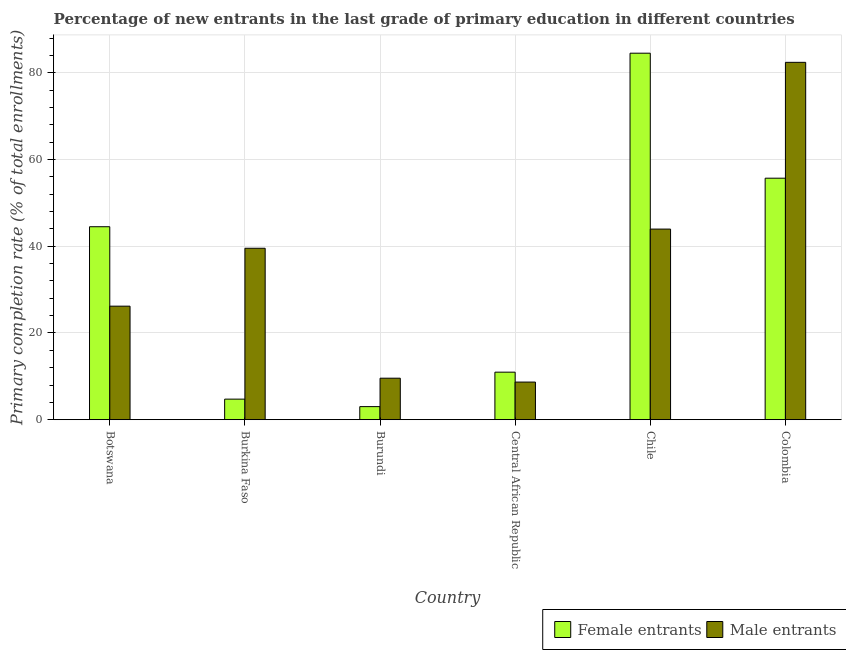Are the number of bars per tick equal to the number of legend labels?
Make the answer very short. Yes. Are the number of bars on each tick of the X-axis equal?
Your answer should be compact. Yes. What is the label of the 3rd group of bars from the left?
Offer a very short reply. Burundi. In how many cases, is the number of bars for a given country not equal to the number of legend labels?
Your response must be concise. 0. What is the primary completion rate of female entrants in Central African Republic?
Your response must be concise. 10.96. Across all countries, what is the maximum primary completion rate of male entrants?
Make the answer very short. 82.42. Across all countries, what is the minimum primary completion rate of female entrants?
Provide a succinct answer. 3.02. In which country was the primary completion rate of female entrants maximum?
Your answer should be compact. Chile. In which country was the primary completion rate of male entrants minimum?
Offer a very short reply. Central African Republic. What is the total primary completion rate of male entrants in the graph?
Give a very brief answer. 210.36. What is the difference between the primary completion rate of male entrants in Burkina Faso and that in Burundi?
Provide a short and direct response. 29.97. What is the difference between the primary completion rate of male entrants in Burkina Faso and the primary completion rate of female entrants in Burundi?
Provide a short and direct response. 36.52. What is the average primary completion rate of male entrants per country?
Your answer should be compact. 35.06. What is the difference between the primary completion rate of female entrants and primary completion rate of male entrants in Chile?
Provide a short and direct response. 40.57. What is the ratio of the primary completion rate of female entrants in Chile to that in Colombia?
Your answer should be very brief. 1.52. Is the primary completion rate of male entrants in Burkina Faso less than that in Central African Republic?
Ensure brevity in your answer.  No. Is the difference between the primary completion rate of male entrants in Botswana and Colombia greater than the difference between the primary completion rate of female entrants in Botswana and Colombia?
Provide a short and direct response. No. What is the difference between the highest and the second highest primary completion rate of male entrants?
Your answer should be compact. 38.46. What is the difference between the highest and the lowest primary completion rate of male entrants?
Offer a very short reply. 73.74. Is the sum of the primary completion rate of male entrants in Burkina Faso and Central African Republic greater than the maximum primary completion rate of female entrants across all countries?
Give a very brief answer. No. What does the 2nd bar from the left in Burundi represents?
Keep it short and to the point. Male entrants. What does the 1st bar from the right in Chile represents?
Provide a succinct answer. Male entrants. How many bars are there?
Keep it short and to the point. 12. What is the difference between two consecutive major ticks on the Y-axis?
Your answer should be very brief. 20. Does the graph contain any zero values?
Make the answer very short. No. Does the graph contain grids?
Your response must be concise. Yes. How are the legend labels stacked?
Give a very brief answer. Horizontal. What is the title of the graph?
Ensure brevity in your answer.  Percentage of new entrants in the last grade of primary education in different countries. What is the label or title of the X-axis?
Provide a succinct answer. Country. What is the label or title of the Y-axis?
Keep it short and to the point. Primary completion rate (% of total enrollments). What is the Primary completion rate (% of total enrollments) in Female entrants in Botswana?
Your answer should be very brief. 44.51. What is the Primary completion rate (% of total enrollments) in Male entrants in Botswana?
Make the answer very short. 26.19. What is the Primary completion rate (% of total enrollments) of Female entrants in Burkina Faso?
Make the answer very short. 4.74. What is the Primary completion rate (% of total enrollments) of Male entrants in Burkina Faso?
Offer a terse response. 39.54. What is the Primary completion rate (% of total enrollments) in Female entrants in Burundi?
Offer a terse response. 3.02. What is the Primary completion rate (% of total enrollments) in Male entrants in Burundi?
Provide a short and direct response. 9.57. What is the Primary completion rate (% of total enrollments) in Female entrants in Central African Republic?
Provide a succinct answer. 10.96. What is the Primary completion rate (% of total enrollments) in Male entrants in Central African Republic?
Make the answer very short. 8.68. What is the Primary completion rate (% of total enrollments) in Female entrants in Chile?
Your answer should be very brief. 84.53. What is the Primary completion rate (% of total enrollments) of Male entrants in Chile?
Your response must be concise. 43.96. What is the Primary completion rate (% of total enrollments) of Female entrants in Colombia?
Your answer should be very brief. 55.7. What is the Primary completion rate (% of total enrollments) of Male entrants in Colombia?
Offer a terse response. 82.42. Across all countries, what is the maximum Primary completion rate (% of total enrollments) of Female entrants?
Offer a very short reply. 84.53. Across all countries, what is the maximum Primary completion rate (% of total enrollments) in Male entrants?
Keep it short and to the point. 82.42. Across all countries, what is the minimum Primary completion rate (% of total enrollments) of Female entrants?
Offer a terse response. 3.02. Across all countries, what is the minimum Primary completion rate (% of total enrollments) of Male entrants?
Keep it short and to the point. 8.68. What is the total Primary completion rate (% of total enrollments) in Female entrants in the graph?
Provide a succinct answer. 203.45. What is the total Primary completion rate (% of total enrollments) of Male entrants in the graph?
Your response must be concise. 210.36. What is the difference between the Primary completion rate (% of total enrollments) of Female entrants in Botswana and that in Burkina Faso?
Offer a terse response. 39.76. What is the difference between the Primary completion rate (% of total enrollments) of Male entrants in Botswana and that in Burkina Faso?
Keep it short and to the point. -13.36. What is the difference between the Primary completion rate (% of total enrollments) of Female entrants in Botswana and that in Burundi?
Make the answer very short. 41.49. What is the difference between the Primary completion rate (% of total enrollments) of Male entrants in Botswana and that in Burundi?
Provide a short and direct response. 16.61. What is the difference between the Primary completion rate (% of total enrollments) of Female entrants in Botswana and that in Central African Republic?
Give a very brief answer. 33.54. What is the difference between the Primary completion rate (% of total enrollments) of Male entrants in Botswana and that in Central African Republic?
Provide a succinct answer. 17.51. What is the difference between the Primary completion rate (% of total enrollments) of Female entrants in Botswana and that in Chile?
Make the answer very short. -40.02. What is the difference between the Primary completion rate (% of total enrollments) of Male entrants in Botswana and that in Chile?
Offer a very short reply. -17.78. What is the difference between the Primary completion rate (% of total enrollments) in Female entrants in Botswana and that in Colombia?
Your answer should be very brief. -11.19. What is the difference between the Primary completion rate (% of total enrollments) in Male entrants in Botswana and that in Colombia?
Make the answer very short. -56.23. What is the difference between the Primary completion rate (% of total enrollments) of Female entrants in Burkina Faso and that in Burundi?
Ensure brevity in your answer.  1.73. What is the difference between the Primary completion rate (% of total enrollments) of Male entrants in Burkina Faso and that in Burundi?
Offer a very short reply. 29.97. What is the difference between the Primary completion rate (% of total enrollments) of Female entrants in Burkina Faso and that in Central African Republic?
Provide a succinct answer. -6.22. What is the difference between the Primary completion rate (% of total enrollments) in Male entrants in Burkina Faso and that in Central African Republic?
Offer a terse response. 30.86. What is the difference between the Primary completion rate (% of total enrollments) of Female entrants in Burkina Faso and that in Chile?
Offer a very short reply. -79.78. What is the difference between the Primary completion rate (% of total enrollments) of Male entrants in Burkina Faso and that in Chile?
Give a very brief answer. -4.42. What is the difference between the Primary completion rate (% of total enrollments) of Female entrants in Burkina Faso and that in Colombia?
Provide a succinct answer. -50.95. What is the difference between the Primary completion rate (% of total enrollments) in Male entrants in Burkina Faso and that in Colombia?
Your answer should be very brief. -42.88. What is the difference between the Primary completion rate (% of total enrollments) of Female entrants in Burundi and that in Central African Republic?
Offer a terse response. -7.94. What is the difference between the Primary completion rate (% of total enrollments) of Male entrants in Burundi and that in Central African Republic?
Give a very brief answer. 0.89. What is the difference between the Primary completion rate (% of total enrollments) in Female entrants in Burundi and that in Chile?
Provide a short and direct response. -81.51. What is the difference between the Primary completion rate (% of total enrollments) of Male entrants in Burundi and that in Chile?
Your answer should be compact. -34.39. What is the difference between the Primary completion rate (% of total enrollments) in Female entrants in Burundi and that in Colombia?
Offer a terse response. -52.68. What is the difference between the Primary completion rate (% of total enrollments) in Male entrants in Burundi and that in Colombia?
Provide a succinct answer. -72.85. What is the difference between the Primary completion rate (% of total enrollments) in Female entrants in Central African Republic and that in Chile?
Provide a succinct answer. -73.57. What is the difference between the Primary completion rate (% of total enrollments) of Male entrants in Central African Republic and that in Chile?
Offer a very short reply. -35.28. What is the difference between the Primary completion rate (% of total enrollments) in Female entrants in Central African Republic and that in Colombia?
Provide a short and direct response. -44.74. What is the difference between the Primary completion rate (% of total enrollments) of Male entrants in Central African Republic and that in Colombia?
Make the answer very short. -73.74. What is the difference between the Primary completion rate (% of total enrollments) in Female entrants in Chile and that in Colombia?
Your answer should be compact. 28.83. What is the difference between the Primary completion rate (% of total enrollments) in Male entrants in Chile and that in Colombia?
Give a very brief answer. -38.46. What is the difference between the Primary completion rate (% of total enrollments) of Female entrants in Botswana and the Primary completion rate (% of total enrollments) of Male entrants in Burkina Faso?
Give a very brief answer. 4.96. What is the difference between the Primary completion rate (% of total enrollments) in Female entrants in Botswana and the Primary completion rate (% of total enrollments) in Male entrants in Burundi?
Provide a succinct answer. 34.93. What is the difference between the Primary completion rate (% of total enrollments) in Female entrants in Botswana and the Primary completion rate (% of total enrollments) in Male entrants in Central African Republic?
Offer a terse response. 35.83. What is the difference between the Primary completion rate (% of total enrollments) of Female entrants in Botswana and the Primary completion rate (% of total enrollments) of Male entrants in Chile?
Your answer should be compact. 0.54. What is the difference between the Primary completion rate (% of total enrollments) in Female entrants in Botswana and the Primary completion rate (% of total enrollments) in Male entrants in Colombia?
Ensure brevity in your answer.  -37.91. What is the difference between the Primary completion rate (% of total enrollments) of Female entrants in Burkina Faso and the Primary completion rate (% of total enrollments) of Male entrants in Burundi?
Your answer should be very brief. -4.83. What is the difference between the Primary completion rate (% of total enrollments) in Female entrants in Burkina Faso and the Primary completion rate (% of total enrollments) in Male entrants in Central African Republic?
Provide a succinct answer. -3.94. What is the difference between the Primary completion rate (% of total enrollments) in Female entrants in Burkina Faso and the Primary completion rate (% of total enrollments) in Male entrants in Chile?
Keep it short and to the point. -39.22. What is the difference between the Primary completion rate (% of total enrollments) in Female entrants in Burkina Faso and the Primary completion rate (% of total enrollments) in Male entrants in Colombia?
Ensure brevity in your answer.  -77.68. What is the difference between the Primary completion rate (% of total enrollments) of Female entrants in Burundi and the Primary completion rate (% of total enrollments) of Male entrants in Central African Republic?
Keep it short and to the point. -5.66. What is the difference between the Primary completion rate (% of total enrollments) in Female entrants in Burundi and the Primary completion rate (% of total enrollments) in Male entrants in Chile?
Offer a terse response. -40.94. What is the difference between the Primary completion rate (% of total enrollments) of Female entrants in Burundi and the Primary completion rate (% of total enrollments) of Male entrants in Colombia?
Provide a short and direct response. -79.4. What is the difference between the Primary completion rate (% of total enrollments) of Female entrants in Central African Republic and the Primary completion rate (% of total enrollments) of Male entrants in Chile?
Your answer should be compact. -33. What is the difference between the Primary completion rate (% of total enrollments) in Female entrants in Central African Republic and the Primary completion rate (% of total enrollments) in Male entrants in Colombia?
Make the answer very short. -71.46. What is the difference between the Primary completion rate (% of total enrollments) of Female entrants in Chile and the Primary completion rate (% of total enrollments) of Male entrants in Colombia?
Offer a very short reply. 2.11. What is the average Primary completion rate (% of total enrollments) of Female entrants per country?
Your response must be concise. 33.91. What is the average Primary completion rate (% of total enrollments) in Male entrants per country?
Provide a succinct answer. 35.06. What is the difference between the Primary completion rate (% of total enrollments) of Female entrants and Primary completion rate (% of total enrollments) of Male entrants in Botswana?
Provide a short and direct response. 18.32. What is the difference between the Primary completion rate (% of total enrollments) in Female entrants and Primary completion rate (% of total enrollments) in Male entrants in Burkina Faso?
Ensure brevity in your answer.  -34.8. What is the difference between the Primary completion rate (% of total enrollments) of Female entrants and Primary completion rate (% of total enrollments) of Male entrants in Burundi?
Make the answer very short. -6.56. What is the difference between the Primary completion rate (% of total enrollments) in Female entrants and Primary completion rate (% of total enrollments) in Male entrants in Central African Republic?
Make the answer very short. 2.28. What is the difference between the Primary completion rate (% of total enrollments) of Female entrants and Primary completion rate (% of total enrollments) of Male entrants in Chile?
Provide a succinct answer. 40.57. What is the difference between the Primary completion rate (% of total enrollments) of Female entrants and Primary completion rate (% of total enrollments) of Male entrants in Colombia?
Provide a short and direct response. -26.72. What is the ratio of the Primary completion rate (% of total enrollments) of Female entrants in Botswana to that in Burkina Faso?
Offer a very short reply. 9.38. What is the ratio of the Primary completion rate (% of total enrollments) of Male entrants in Botswana to that in Burkina Faso?
Keep it short and to the point. 0.66. What is the ratio of the Primary completion rate (% of total enrollments) in Female entrants in Botswana to that in Burundi?
Ensure brevity in your answer.  14.75. What is the ratio of the Primary completion rate (% of total enrollments) in Male entrants in Botswana to that in Burundi?
Your answer should be very brief. 2.74. What is the ratio of the Primary completion rate (% of total enrollments) in Female entrants in Botswana to that in Central African Republic?
Offer a terse response. 4.06. What is the ratio of the Primary completion rate (% of total enrollments) in Male entrants in Botswana to that in Central African Republic?
Offer a terse response. 3.02. What is the ratio of the Primary completion rate (% of total enrollments) of Female entrants in Botswana to that in Chile?
Offer a very short reply. 0.53. What is the ratio of the Primary completion rate (% of total enrollments) of Male entrants in Botswana to that in Chile?
Ensure brevity in your answer.  0.6. What is the ratio of the Primary completion rate (% of total enrollments) in Female entrants in Botswana to that in Colombia?
Provide a short and direct response. 0.8. What is the ratio of the Primary completion rate (% of total enrollments) of Male entrants in Botswana to that in Colombia?
Your answer should be very brief. 0.32. What is the ratio of the Primary completion rate (% of total enrollments) in Female entrants in Burkina Faso to that in Burundi?
Keep it short and to the point. 1.57. What is the ratio of the Primary completion rate (% of total enrollments) in Male entrants in Burkina Faso to that in Burundi?
Offer a very short reply. 4.13. What is the ratio of the Primary completion rate (% of total enrollments) of Female entrants in Burkina Faso to that in Central African Republic?
Provide a succinct answer. 0.43. What is the ratio of the Primary completion rate (% of total enrollments) of Male entrants in Burkina Faso to that in Central African Republic?
Offer a very short reply. 4.56. What is the ratio of the Primary completion rate (% of total enrollments) in Female entrants in Burkina Faso to that in Chile?
Your answer should be compact. 0.06. What is the ratio of the Primary completion rate (% of total enrollments) in Male entrants in Burkina Faso to that in Chile?
Provide a short and direct response. 0.9. What is the ratio of the Primary completion rate (% of total enrollments) in Female entrants in Burkina Faso to that in Colombia?
Ensure brevity in your answer.  0.09. What is the ratio of the Primary completion rate (% of total enrollments) in Male entrants in Burkina Faso to that in Colombia?
Your answer should be very brief. 0.48. What is the ratio of the Primary completion rate (% of total enrollments) of Female entrants in Burundi to that in Central African Republic?
Provide a short and direct response. 0.28. What is the ratio of the Primary completion rate (% of total enrollments) in Male entrants in Burundi to that in Central African Republic?
Make the answer very short. 1.1. What is the ratio of the Primary completion rate (% of total enrollments) of Female entrants in Burundi to that in Chile?
Your response must be concise. 0.04. What is the ratio of the Primary completion rate (% of total enrollments) of Male entrants in Burundi to that in Chile?
Your answer should be compact. 0.22. What is the ratio of the Primary completion rate (% of total enrollments) of Female entrants in Burundi to that in Colombia?
Keep it short and to the point. 0.05. What is the ratio of the Primary completion rate (% of total enrollments) in Male entrants in Burundi to that in Colombia?
Your answer should be compact. 0.12. What is the ratio of the Primary completion rate (% of total enrollments) of Female entrants in Central African Republic to that in Chile?
Your answer should be very brief. 0.13. What is the ratio of the Primary completion rate (% of total enrollments) in Male entrants in Central African Republic to that in Chile?
Offer a very short reply. 0.2. What is the ratio of the Primary completion rate (% of total enrollments) of Female entrants in Central African Republic to that in Colombia?
Your response must be concise. 0.2. What is the ratio of the Primary completion rate (% of total enrollments) in Male entrants in Central African Republic to that in Colombia?
Give a very brief answer. 0.11. What is the ratio of the Primary completion rate (% of total enrollments) of Female entrants in Chile to that in Colombia?
Your response must be concise. 1.52. What is the ratio of the Primary completion rate (% of total enrollments) of Male entrants in Chile to that in Colombia?
Your response must be concise. 0.53. What is the difference between the highest and the second highest Primary completion rate (% of total enrollments) in Female entrants?
Your answer should be compact. 28.83. What is the difference between the highest and the second highest Primary completion rate (% of total enrollments) of Male entrants?
Your answer should be very brief. 38.46. What is the difference between the highest and the lowest Primary completion rate (% of total enrollments) in Female entrants?
Provide a short and direct response. 81.51. What is the difference between the highest and the lowest Primary completion rate (% of total enrollments) of Male entrants?
Your answer should be compact. 73.74. 